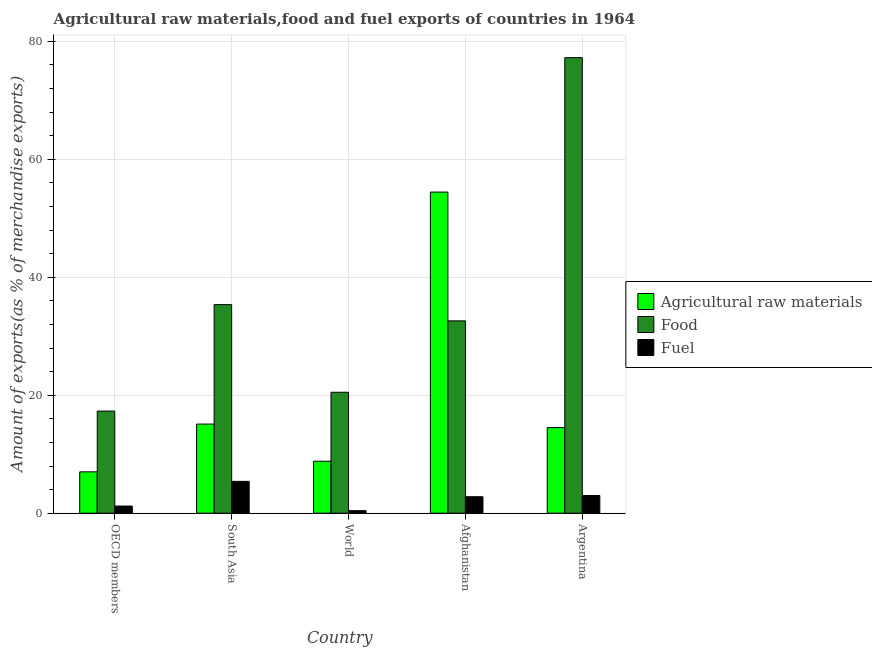How many bars are there on the 5th tick from the left?
Offer a very short reply. 3. How many bars are there on the 1st tick from the right?
Offer a very short reply. 3. What is the percentage of raw materials exports in Afghanistan?
Offer a terse response. 54.44. Across all countries, what is the maximum percentage of fuel exports?
Give a very brief answer. 5.4. Across all countries, what is the minimum percentage of raw materials exports?
Your response must be concise. 7.01. What is the total percentage of fuel exports in the graph?
Provide a short and direct response. 12.83. What is the difference between the percentage of food exports in Afghanistan and that in South Asia?
Provide a short and direct response. -2.76. What is the difference between the percentage of fuel exports in South Asia and the percentage of raw materials exports in World?
Give a very brief answer. -3.41. What is the average percentage of fuel exports per country?
Your answer should be very brief. 2.57. What is the difference between the percentage of fuel exports and percentage of raw materials exports in South Asia?
Your response must be concise. -9.71. In how many countries, is the percentage of raw materials exports greater than 40 %?
Your answer should be very brief. 1. What is the ratio of the percentage of food exports in Afghanistan to that in South Asia?
Offer a very short reply. 0.92. Is the difference between the percentage of food exports in Afghanistan and Argentina greater than the difference between the percentage of raw materials exports in Afghanistan and Argentina?
Provide a succinct answer. No. What is the difference between the highest and the second highest percentage of food exports?
Give a very brief answer. 41.87. What is the difference between the highest and the lowest percentage of fuel exports?
Provide a short and direct response. 4.97. What does the 2nd bar from the left in South Asia represents?
Make the answer very short. Food. What does the 2nd bar from the right in OECD members represents?
Give a very brief answer. Food. How many countries are there in the graph?
Give a very brief answer. 5. Does the graph contain any zero values?
Ensure brevity in your answer.  No. Does the graph contain grids?
Offer a very short reply. Yes. How many legend labels are there?
Your response must be concise. 3. How are the legend labels stacked?
Your answer should be very brief. Vertical. What is the title of the graph?
Keep it short and to the point. Agricultural raw materials,food and fuel exports of countries in 1964. What is the label or title of the X-axis?
Make the answer very short. Country. What is the label or title of the Y-axis?
Offer a very short reply. Amount of exports(as % of merchandise exports). What is the Amount of exports(as % of merchandise exports) in Agricultural raw materials in OECD members?
Offer a terse response. 7.01. What is the Amount of exports(as % of merchandise exports) of Food in OECD members?
Provide a succinct answer. 17.31. What is the Amount of exports(as % of merchandise exports) of Fuel in OECD members?
Your answer should be very brief. 1.21. What is the Amount of exports(as % of merchandise exports) of Agricultural raw materials in South Asia?
Offer a very short reply. 15.11. What is the Amount of exports(as % of merchandise exports) in Food in South Asia?
Ensure brevity in your answer.  35.36. What is the Amount of exports(as % of merchandise exports) of Fuel in South Asia?
Your answer should be compact. 5.4. What is the Amount of exports(as % of merchandise exports) in Agricultural raw materials in World?
Offer a terse response. 8.81. What is the Amount of exports(as % of merchandise exports) of Food in World?
Ensure brevity in your answer.  20.5. What is the Amount of exports(as % of merchandise exports) of Fuel in World?
Keep it short and to the point. 0.43. What is the Amount of exports(as % of merchandise exports) of Agricultural raw materials in Afghanistan?
Your answer should be compact. 54.44. What is the Amount of exports(as % of merchandise exports) of Food in Afghanistan?
Ensure brevity in your answer.  32.6. What is the Amount of exports(as % of merchandise exports) of Fuel in Afghanistan?
Offer a very short reply. 2.79. What is the Amount of exports(as % of merchandise exports) in Agricultural raw materials in Argentina?
Keep it short and to the point. 14.52. What is the Amount of exports(as % of merchandise exports) in Food in Argentina?
Your answer should be compact. 77.23. What is the Amount of exports(as % of merchandise exports) of Fuel in Argentina?
Offer a terse response. 3. Across all countries, what is the maximum Amount of exports(as % of merchandise exports) in Agricultural raw materials?
Make the answer very short. 54.44. Across all countries, what is the maximum Amount of exports(as % of merchandise exports) of Food?
Your answer should be compact. 77.23. Across all countries, what is the maximum Amount of exports(as % of merchandise exports) in Fuel?
Your answer should be compact. 5.4. Across all countries, what is the minimum Amount of exports(as % of merchandise exports) of Agricultural raw materials?
Your answer should be very brief. 7.01. Across all countries, what is the minimum Amount of exports(as % of merchandise exports) in Food?
Offer a terse response. 17.31. Across all countries, what is the minimum Amount of exports(as % of merchandise exports) in Fuel?
Offer a very short reply. 0.43. What is the total Amount of exports(as % of merchandise exports) of Agricultural raw materials in the graph?
Ensure brevity in your answer.  99.89. What is the total Amount of exports(as % of merchandise exports) of Food in the graph?
Give a very brief answer. 183.01. What is the total Amount of exports(as % of merchandise exports) of Fuel in the graph?
Keep it short and to the point. 12.83. What is the difference between the Amount of exports(as % of merchandise exports) in Agricultural raw materials in OECD members and that in South Asia?
Your answer should be very brief. -8.1. What is the difference between the Amount of exports(as % of merchandise exports) of Food in OECD members and that in South Asia?
Offer a very short reply. -18.05. What is the difference between the Amount of exports(as % of merchandise exports) of Fuel in OECD members and that in South Asia?
Your answer should be compact. -4.19. What is the difference between the Amount of exports(as % of merchandise exports) of Agricultural raw materials in OECD members and that in World?
Your response must be concise. -1.8. What is the difference between the Amount of exports(as % of merchandise exports) of Food in OECD members and that in World?
Provide a short and direct response. -3.19. What is the difference between the Amount of exports(as % of merchandise exports) in Fuel in OECD members and that in World?
Offer a terse response. 0.78. What is the difference between the Amount of exports(as % of merchandise exports) in Agricultural raw materials in OECD members and that in Afghanistan?
Your response must be concise. -47.42. What is the difference between the Amount of exports(as % of merchandise exports) in Food in OECD members and that in Afghanistan?
Your answer should be compact. -15.29. What is the difference between the Amount of exports(as % of merchandise exports) of Fuel in OECD members and that in Afghanistan?
Keep it short and to the point. -1.58. What is the difference between the Amount of exports(as % of merchandise exports) of Agricultural raw materials in OECD members and that in Argentina?
Give a very brief answer. -7.5. What is the difference between the Amount of exports(as % of merchandise exports) of Food in OECD members and that in Argentina?
Your answer should be very brief. -59.91. What is the difference between the Amount of exports(as % of merchandise exports) in Fuel in OECD members and that in Argentina?
Provide a short and direct response. -1.78. What is the difference between the Amount of exports(as % of merchandise exports) in Agricultural raw materials in South Asia and that in World?
Keep it short and to the point. 6.3. What is the difference between the Amount of exports(as % of merchandise exports) of Food in South Asia and that in World?
Offer a very short reply. 14.86. What is the difference between the Amount of exports(as % of merchandise exports) in Fuel in South Asia and that in World?
Provide a succinct answer. 4.97. What is the difference between the Amount of exports(as % of merchandise exports) in Agricultural raw materials in South Asia and that in Afghanistan?
Ensure brevity in your answer.  -39.33. What is the difference between the Amount of exports(as % of merchandise exports) of Food in South Asia and that in Afghanistan?
Your response must be concise. 2.76. What is the difference between the Amount of exports(as % of merchandise exports) in Fuel in South Asia and that in Afghanistan?
Your response must be concise. 2.61. What is the difference between the Amount of exports(as % of merchandise exports) in Agricultural raw materials in South Asia and that in Argentina?
Your answer should be very brief. 0.59. What is the difference between the Amount of exports(as % of merchandise exports) of Food in South Asia and that in Argentina?
Your answer should be very brief. -41.87. What is the difference between the Amount of exports(as % of merchandise exports) of Fuel in South Asia and that in Argentina?
Your response must be concise. 2.4. What is the difference between the Amount of exports(as % of merchandise exports) of Agricultural raw materials in World and that in Afghanistan?
Offer a terse response. -45.63. What is the difference between the Amount of exports(as % of merchandise exports) of Food in World and that in Afghanistan?
Provide a succinct answer. -12.1. What is the difference between the Amount of exports(as % of merchandise exports) in Fuel in World and that in Afghanistan?
Provide a short and direct response. -2.36. What is the difference between the Amount of exports(as % of merchandise exports) of Agricultural raw materials in World and that in Argentina?
Your answer should be very brief. -5.71. What is the difference between the Amount of exports(as % of merchandise exports) in Food in World and that in Argentina?
Give a very brief answer. -56.72. What is the difference between the Amount of exports(as % of merchandise exports) of Fuel in World and that in Argentina?
Your response must be concise. -2.56. What is the difference between the Amount of exports(as % of merchandise exports) in Agricultural raw materials in Afghanistan and that in Argentina?
Your answer should be compact. 39.92. What is the difference between the Amount of exports(as % of merchandise exports) in Food in Afghanistan and that in Argentina?
Make the answer very short. -44.62. What is the difference between the Amount of exports(as % of merchandise exports) in Fuel in Afghanistan and that in Argentina?
Offer a terse response. -0.2. What is the difference between the Amount of exports(as % of merchandise exports) of Agricultural raw materials in OECD members and the Amount of exports(as % of merchandise exports) of Food in South Asia?
Your answer should be compact. -28.35. What is the difference between the Amount of exports(as % of merchandise exports) in Agricultural raw materials in OECD members and the Amount of exports(as % of merchandise exports) in Fuel in South Asia?
Ensure brevity in your answer.  1.61. What is the difference between the Amount of exports(as % of merchandise exports) in Food in OECD members and the Amount of exports(as % of merchandise exports) in Fuel in South Asia?
Ensure brevity in your answer.  11.92. What is the difference between the Amount of exports(as % of merchandise exports) in Agricultural raw materials in OECD members and the Amount of exports(as % of merchandise exports) in Food in World?
Offer a terse response. -13.49. What is the difference between the Amount of exports(as % of merchandise exports) of Agricultural raw materials in OECD members and the Amount of exports(as % of merchandise exports) of Fuel in World?
Give a very brief answer. 6.58. What is the difference between the Amount of exports(as % of merchandise exports) in Food in OECD members and the Amount of exports(as % of merchandise exports) in Fuel in World?
Your response must be concise. 16.88. What is the difference between the Amount of exports(as % of merchandise exports) in Agricultural raw materials in OECD members and the Amount of exports(as % of merchandise exports) in Food in Afghanistan?
Keep it short and to the point. -25.59. What is the difference between the Amount of exports(as % of merchandise exports) in Agricultural raw materials in OECD members and the Amount of exports(as % of merchandise exports) in Fuel in Afghanistan?
Offer a very short reply. 4.22. What is the difference between the Amount of exports(as % of merchandise exports) of Food in OECD members and the Amount of exports(as % of merchandise exports) of Fuel in Afghanistan?
Your answer should be very brief. 14.52. What is the difference between the Amount of exports(as % of merchandise exports) in Agricultural raw materials in OECD members and the Amount of exports(as % of merchandise exports) in Food in Argentina?
Give a very brief answer. -70.21. What is the difference between the Amount of exports(as % of merchandise exports) in Agricultural raw materials in OECD members and the Amount of exports(as % of merchandise exports) in Fuel in Argentina?
Make the answer very short. 4.02. What is the difference between the Amount of exports(as % of merchandise exports) of Food in OECD members and the Amount of exports(as % of merchandise exports) of Fuel in Argentina?
Your answer should be very brief. 14.32. What is the difference between the Amount of exports(as % of merchandise exports) of Agricultural raw materials in South Asia and the Amount of exports(as % of merchandise exports) of Food in World?
Provide a short and direct response. -5.39. What is the difference between the Amount of exports(as % of merchandise exports) of Agricultural raw materials in South Asia and the Amount of exports(as % of merchandise exports) of Fuel in World?
Your response must be concise. 14.68. What is the difference between the Amount of exports(as % of merchandise exports) of Food in South Asia and the Amount of exports(as % of merchandise exports) of Fuel in World?
Offer a terse response. 34.93. What is the difference between the Amount of exports(as % of merchandise exports) in Agricultural raw materials in South Asia and the Amount of exports(as % of merchandise exports) in Food in Afghanistan?
Your answer should be very brief. -17.49. What is the difference between the Amount of exports(as % of merchandise exports) in Agricultural raw materials in South Asia and the Amount of exports(as % of merchandise exports) in Fuel in Afghanistan?
Your response must be concise. 12.32. What is the difference between the Amount of exports(as % of merchandise exports) in Food in South Asia and the Amount of exports(as % of merchandise exports) in Fuel in Afghanistan?
Your answer should be compact. 32.57. What is the difference between the Amount of exports(as % of merchandise exports) in Agricultural raw materials in South Asia and the Amount of exports(as % of merchandise exports) in Food in Argentina?
Ensure brevity in your answer.  -62.12. What is the difference between the Amount of exports(as % of merchandise exports) in Agricultural raw materials in South Asia and the Amount of exports(as % of merchandise exports) in Fuel in Argentina?
Provide a short and direct response. 12.11. What is the difference between the Amount of exports(as % of merchandise exports) in Food in South Asia and the Amount of exports(as % of merchandise exports) in Fuel in Argentina?
Your response must be concise. 32.36. What is the difference between the Amount of exports(as % of merchandise exports) in Agricultural raw materials in World and the Amount of exports(as % of merchandise exports) in Food in Afghanistan?
Your answer should be compact. -23.79. What is the difference between the Amount of exports(as % of merchandise exports) of Agricultural raw materials in World and the Amount of exports(as % of merchandise exports) of Fuel in Afghanistan?
Make the answer very short. 6.02. What is the difference between the Amount of exports(as % of merchandise exports) in Food in World and the Amount of exports(as % of merchandise exports) in Fuel in Afghanistan?
Provide a short and direct response. 17.71. What is the difference between the Amount of exports(as % of merchandise exports) in Agricultural raw materials in World and the Amount of exports(as % of merchandise exports) in Food in Argentina?
Your response must be concise. -68.42. What is the difference between the Amount of exports(as % of merchandise exports) of Agricultural raw materials in World and the Amount of exports(as % of merchandise exports) of Fuel in Argentina?
Provide a short and direct response. 5.81. What is the difference between the Amount of exports(as % of merchandise exports) of Food in World and the Amount of exports(as % of merchandise exports) of Fuel in Argentina?
Give a very brief answer. 17.51. What is the difference between the Amount of exports(as % of merchandise exports) in Agricultural raw materials in Afghanistan and the Amount of exports(as % of merchandise exports) in Food in Argentina?
Offer a terse response. -22.79. What is the difference between the Amount of exports(as % of merchandise exports) of Agricultural raw materials in Afghanistan and the Amount of exports(as % of merchandise exports) of Fuel in Argentina?
Give a very brief answer. 51.44. What is the difference between the Amount of exports(as % of merchandise exports) in Food in Afghanistan and the Amount of exports(as % of merchandise exports) in Fuel in Argentina?
Give a very brief answer. 29.61. What is the average Amount of exports(as % of merchandise exports) in Agricultural raw materials per country?
Offer a terse response. 19.98. What is the average Amount of exports(as % of merchandise exports) of Food per country?
Make the answer very short. 36.6. What is the average Amount of exports(as % of merchandise exports) of Fuel per country?
Provide a short and direct response. 2.57. What is the difference between the Amount of exports(as % of merchandise exports) in Agricultural raw materials and Amount of exports(as % of merchandise exports) in Food in OECD members?
Ensure brevity in your answer.  -10.3. What is the difference between the Amount of exports(as % of merchandise exports) in Agricultural raw materials and Amount of exports(as % of merchandise exports) in Fuel in OECD members?
Give a very brief answer. 5.8. What is the difference between the Amount of exports(as % of merchandise exports) of Food and Amount of exports(as % of merchandise exports) of Fuel in OECD members?
Make the answer very short. 16.1. What is the difference between the Amount of exports(as % of merchandise exports) of Agricultural raw materials and Amount of exports(as % of merchandise exports) of Food in South Asia?
Your response must be concise. -20.25. What is the difference between the Amount of exports(as % of merchandise exports) in Agricultural raw materials and Amount of exports(as % of merchandise exports) in Fuel in South Asia?
Your answer should be compact. 9.71. What is the difference between the Amount of exports(as % of merchandise exports) of Food and Amount of exports(as % of merchandise exports) of Fuel in South Asia?
Keep it short and to the point. 29.96. What is the difference between the Amount of exports(as % of merchandise exports) of Agricultural raw materials and Amount of exports(as % of merchandise exports) of Food in World?
Your response must be concise. -11.69. What is the difference between the Amount of exports(as % of merchandise exports) of Agricultural raw materials and Amount of exports(as % of merchandise exports) of Fuel in World?
Give a very brief answer. 8.38. What is the difference between the Amount of exports(as % of merchandise exports) of Food and Amount of exports(as % of merchandise exports) of Fuel in World?
Your answer should be very brief. 20.07. What is the difference between the Amount of exports(as % of merchandise exports) in Agricultural raw materials and Amount of exports(as % of merchandise exports) in Food in Afghanistan?
Keep it short and to the point. 21.83. What is the difference between the Amount of exports(as % of merchandise exports) in Agricultural raw materials and Amount of exports(as % of merchandise exports) in Fuel in Afghanistan?
Make the answer very short. 51.64. What is the difference between the Amount of exports(as % of merchandise exports) in Food and Amount of exports(as % of merchandise exports) in Fuel in Afghanistan?
Your answer should be compact. 29.81. What is the difference between the Amount of exports(as % of merchandise exports) of Agricultural raw materials and Amount of exports(as % of merchandise exports) of Food in Argentina?
Your answer should be compact. -62.71. What is the difference between the Amount of exports(as % of merchandise exports) of Agricultural raw materials and Amount of exports(as % of merchandise exports) of Fuel in Argentina?
Provide a succinct answer. 11.52. What is the difference between the Amount of exports(as % of merchandise exports) in Food and Amount of exports(as % of merchandise exports) in Fuel in Argentina?
Your answer should be very brief. 74.23. What is the ratio of the Amount of exports(as % of merchandise exports) in Agricultural raw materials in OECD members to that in South Asia?
Give a very brief answer. 0.46. What is the ratio of the Amount of exports(as % of merchandise exports) in Food in OECD members to that in South Asia?
Provide a short and direct response. 0.49. What is the ratio of the Amount of exports(as % of merchandise exports) in Fuel in OECD members to that in South Asia?
Make the answer very short. 0.22. What is the ratio of the Amount of exports(as % of merchandise exports) in Agricultural raw materials in OECD members to that in World?
Your answer should be very brief. 0.8. What is the ratio of the Amount of exports(as % of merchandise exports) of Food in OECD members to that in World?
Provide a succinct answer. 0.84. What is the ratio of the Amount of exports(as % of merchandise exports) of Fuel in OECD members to that in World?
Your answer should be compact. 2.8. What is the ratio of the Amount of exports(as % of merchandise exports) of Agricultural raw materials in OECD members to that in Afghanistan?
Provide a succinct answer. 0.13. What is the ratio of the Amount of exports(as % of merchandise exports) in Food in OECD members to that in Afghanistan?
Your answer should be very brief. 0.53. What is the ratio of the Amount of exports(as % of merchandise exports) of Fuel in OECD members to that in Afghanistan?
Your answer should be compact. 0.43. What is the ratio of the Amount of exports(as % of merchandise exports) in Agricultural raw materials in OECD members to that in Argentina?
Make the answer very short. 0.48. What is the ratio of the Amount of exports(as % of merchandise exports) of Food in OECD members to that in Argentina?
Keep it short and to the point. 0.22. What is the ratio of the Amount of exports(as % of merchandise exports) of Fuel in OECD members to that in Argentina?
Give a very brief answer. 0.4. What is the ratio of the Amount of exports(as % of merchandise exports) of Agricultural raw materials in South Asia to that in World?
Provide a short and direct response. 1.72. What is the ratio of the Amount of exports(as % of merchandise exports) of Food in South Asia to that in World?
Ensure brevity in your answer.  1.72. What is the ratio of the Amount of exports(as % of merchandise exports) in Fuel in South Asia to that in World?
Provide a succinct answer. 12.49. What is the ratio of the Amount of exports(as % of merchandise exports) in Agricultural raw materials in South Asia to that in Afghanistan?
Your response must be concise. 0.28. What is the ratio of the Amount of exports(as % of merchandise exports) in Food in South Asia to that in Afghanistan?
Your answer should be compact. 1.08. What is the ratio of the Amount of exports(as % of merchandise exports) of Fuel in South Asia to that in Afghanistan?
Your response must be concise. 1.93. What is the ratio of the Amount of exports(as % of merchandise exports) in Agricultural raw materials in South Asia to that in Argentina?
Offer a very short reply. 1.04. What is the ratio of the Amount of exports(as % of merchandise exports) in Food in South Asia to that in Argentina?
Your response must be concise. 0.46. What is the ratio of the Amount of exports(as % of merchandise exports) of Fuel in South Asia to that in Argentina?
Keep it short and to the point. 1.8. What is the ratio of the Amount of exports(as % of merchandise exports) of Agricultural raw materials in World to that in Afghanistan?
Make the answer very short. 0.16. What is the ratio of the Amount of exports(as % of merchandise exports) in Food in World to that in Afghanistan?
Your answer should be very brief. 0.63. What is the ratio of the Amount of exports(as % of merchandise exports) in Fuel in World to that in Afghanistan?
Offer a terse response. 0.15. What is the ratio of the Amount of exports(as % of merchandise exports) in Agricultural raw materials in World to that in Argentina?
Give a very brief answer. 0.61. What is the ratio of the Amount of exports(as % of merchandise exports) in Food in World to that in Argentina?
Ensure brevity in your answer.  0.27. What is the ratio of the Amount of exports(as % of merchandise exports) in Fuel in World to that in Argentina?
Provide a succinct answer. 0.14. What is the ratio of the Amount of exports(as % of merchandise exports) of Agricultural raw materials in Afghanistan to that in Argentina?
Make the answer very short. 3.75. What is the ratio of the Amount of exports(as % of merchandise exports) of Food in Afghanistan to that in Argentina?
Your response must be concise. 0.42. What is the ratio of the Amount of exports(as % of merchandise exports) of Fuel in Afghanistan to that in Argentina?
Offer a terse response. 0.93. What is the difference between the highest and the second highest Amount of exports(as % of merchandise exports) in Agricultural raw materials?
Ensure brevity in your answer.  39.33. What is the difference between the highest and the second highest Amount of exports(as % of merchandise exports) of Food?
Your answer should be compact. 41.87. What is the difference between the highest and the second highest Amount of exports(as % of merchandise exports) in Fuel?
Provide a short and direct response. 2.4. What is the difference between the highest and the lowest Amount of exports(as % of merchandise exports) in Agricultural raw materials?
Offer a very short reply. 47.42. What is the difference between the highest and the lowest Amount of exports(as % of merchandise exports) of Food?
Offer a terse response. 59.91. What is the difference between the highest and the lowest Amount of exports(as % of merchandise exports) in Fuel?
Give a very brief answer. 4.97. 